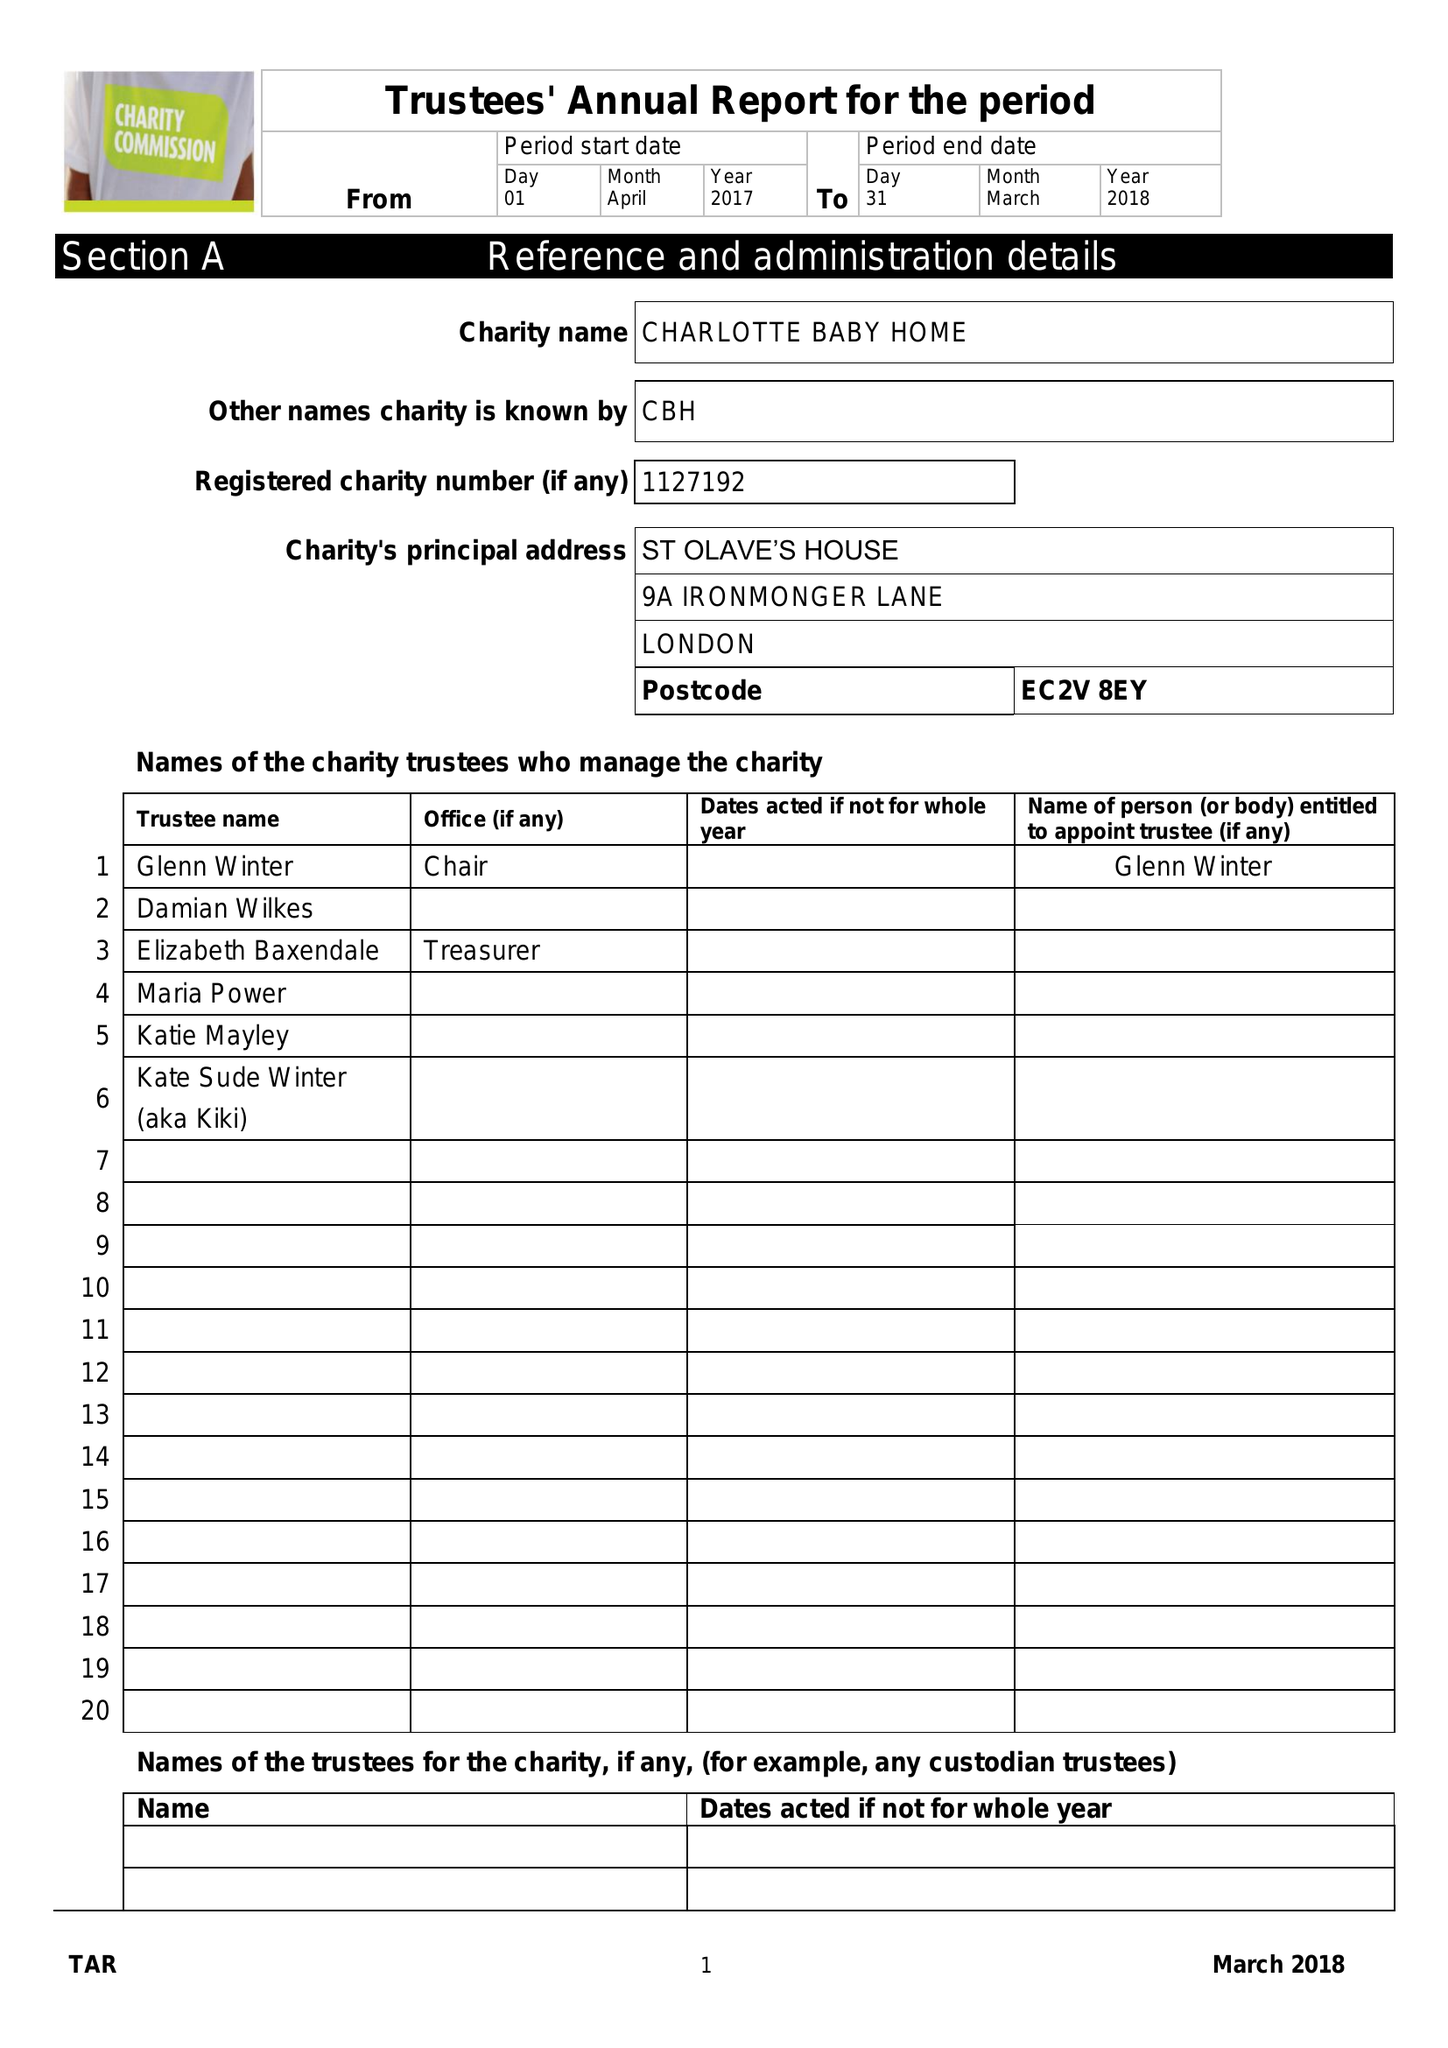What is the value for the charity_name?
Answer the question using a single word or phrase. Charlotte Baby Home 